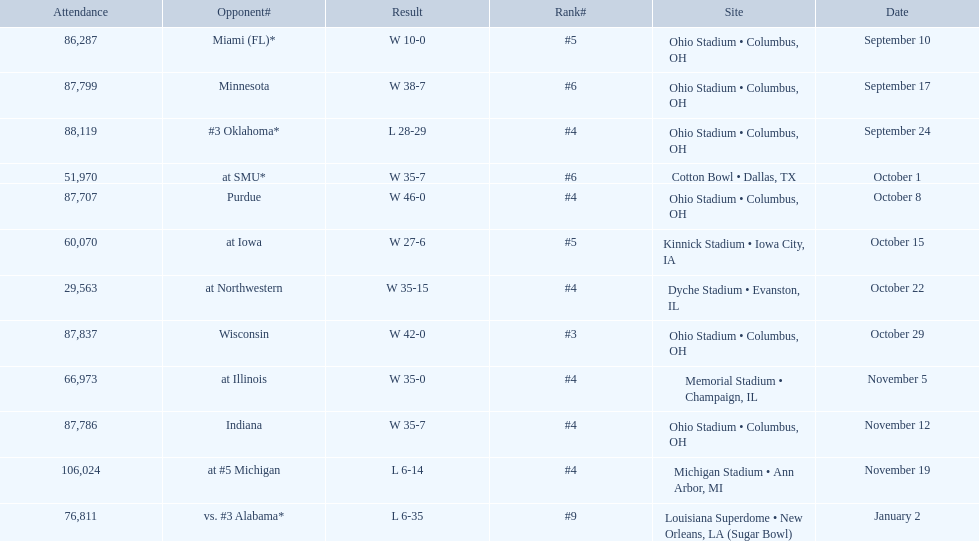In how many games were than more than 80,000 people attending 7. 